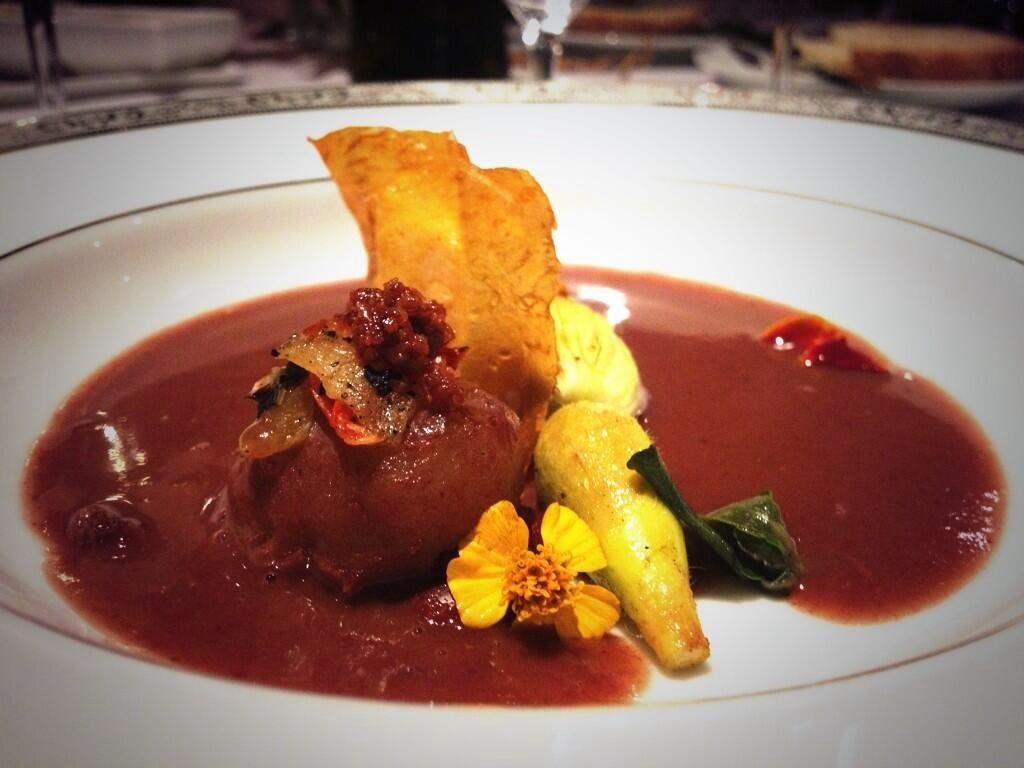What is present in the image? There is food in the image. How is the food arranged or displayed? The food is in a plate. What type of business is being conducted in the image? There is no indication of any business activity in the image; it only shows food in a plate. 